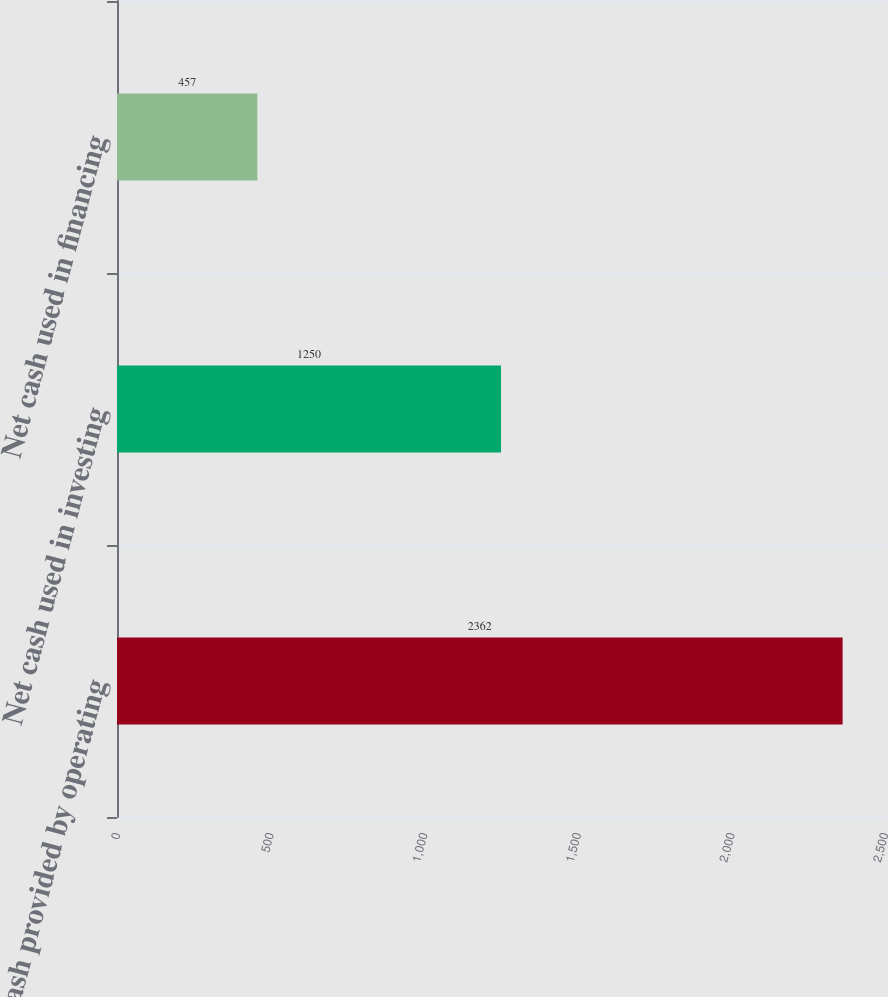Convert chart to OTSL. <chart><loc_0><loc_0><loc_500><loc_500><bar_chart><fcel>Net cash provided by operating<fcel>Net cash used in investing<fcel>Net cash used in financing<nl><fcel>2362<fcel>1250<fcel>457<nl></chart> 